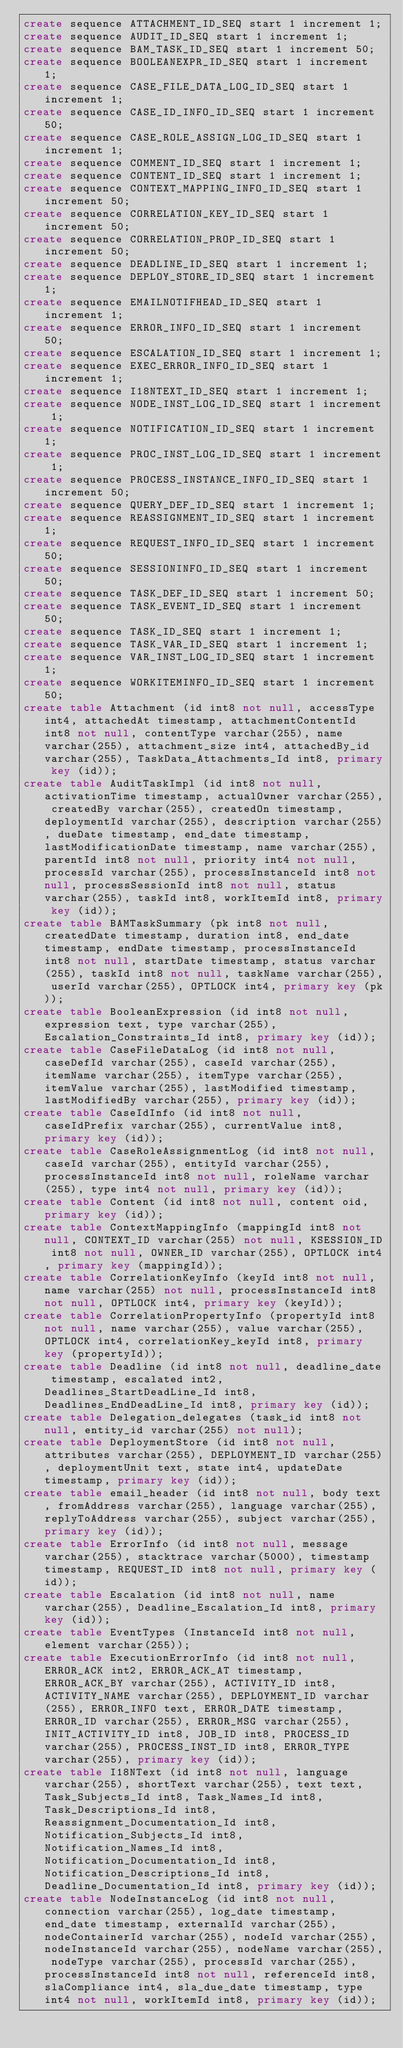<code> <loc_0><loc_0><loc_500><loc_500><_SQL_>create sequence ATTACHMENT_ID_SEQ start 1 increment 1;
create sequence AUDIT_ID_SEQ start 1 increment 1;
create sequence BAM_TASK_ID_SEQ start 1 increment 50;
create sequence BOOLEANEXPR_ID_SEQ start 1 increment 1;
create sequence CASE_FILE_DATA_LOG_ID_SEQ start 1 increment 1;
create sequence CASE_ID_INFO_ID_SEQ start 1 increment 50;
create sequence CASE_ROLE_ASSIGN_LOG_ID_SEQ start 1 increment 1;
create sequence COMMENT_ID_SEQ start 1 increment 1;
create sequence CONTENT_ID_SEQ start 1 increment 1;
create sequence CONTEXT_MAPPING_INFO_ID_SEQ start 1 increment 50;
create sequence CORRELATION_KEY_ID_SEQ start 1 increment 50;
create sequence CORRELATION_PROP_ID_SEQ start 1 increment 50;
create sequence DEADLINE_ID_SEQ start 1 increment 1;
create sequence DEPLOY_STORE_ID_SEQ start 1 increment 1;
create sequence EMAILNOTIFHEAD_ID_SEQ start 1 increment 1;
create sequence ERROR_INFO_ID_SEQ start 1 increment 50;
create sequence ESCALATION_ID_SEQ start 1 increment 1;
create sequence EXEC_ERROR_INFO_ID_SEQ start 1 increment 1;
create sequence I18NTEXT_ID_SEQ start 1 increment 1;
create sequence NODE_INST_LOG_ID_SEQ start 1 increment 1;
create sequence NOTIFICATION_ID_SEQ start 1 increment 1;
create sequence PROC_INST_LOG_ID_SEQ start 1 increment 1;
create sequence PROCESS_INSTANCE_INFO_ID_SEQ start 1 increment 50;
create sequence QUERY_DEF_ID_SEQ start 1 increment 1;
create sequence REASSIGNMENT_ID_SEQ start 1 increment 1;
create sequence REQUEST_INFO_ID_SEQ start 1 increment 50;
create sequence SESSIONINFO_ID_SEQ start 1 increment 50;
create sequence TASK_DEF_ID_SEQ start 1 increment 50;
create sequence TASK_EVENT_ID_SEQ start 1 increment 50;
create sequence TASK_ID_SEQ start 1 increment 1;
create sequence TASK_VAR_ID_SEQ start 1 increment 1;
create sequence VAR_INST_LOG_ID_SEQ start 1 increment 1;
create sequence WORKITEMINFO_ID_SEQ start 1 increment 50;
create table Attachment (id int8 not null, accessType int4, attachedAt timestamp, attachmentContentId int8 not null, contentType varchar(255), name varchar(255), attachment_size int4, attachedBy_id varchar(255), TaskData_Attachments_Id int8, primary key (id));
create table AuditTaskImpl (id int8 not null, activationTime timestamp, actualOwner varchar(255), createdBy varchar(255), createdOn timestamp, deploymentId varchar(255), description varchar(255), dueDate timestamp, end_date timestamp, lastModificationDate timestamp, name varchar(255), parentId int8 not null, priority int4 not null, processId varchar(255), processInstanceId int8 not null, processSessionId int8 not null, status varchar(255), taskId int8, workItemId int8, primary key (id));
create table BAMTaskSummary (pk int8 not null, createdDate timestamp, duration int8, end_date timestamp, endDate timestamp, processInstanceId int8 not null, startDate timestamp, status varchar(255), taskId int8 not null, taskName varchar(255), userId varchar(255), OPTLOCK int4, primary key (pk));
create table BooleanExpression (id int8 not null, expression text, type varchar(255), Escalation_Constraints_Id int8, primary key (id));
create table CaseFileDataLog (id int8 not null, caseDefId varchar(255), caseId varchar(255), itemName varchar(255), itemType varchar(255), itemValue varchar(255), lastModified timestamp, lastModifiedBy varchar(255), primary key (id));
create table CaseIdInfo (id int8 not null, caseIdPrefix varchar(255), currentValue int8, primary key (id));
create table CaseRoleAssignmentLog (id int8 not null, caseId varchar(255), entityId varchar(255), processInstanceId int8 not null, roleName varchar(255), type int4 not null, primary key (id));
create table Content (id int8 not null, content oid, primary key (id));
create table ContextMappingInfo (mappingId int8 not null, CONTEXT_ID varchar(255) not null, KSESSION_ID int8 not null, OWNER_ID varchar(255), OPTLOCK int4, primary key (mappingId));
create table CorrelationKeyInfo (keyId int8 not null, name varchar(255) not null, processInstanceId int8 not null, OPTLOCK int4, primary key (keyId));
create table CorrelationPropertyInfo (propertyId int8 not null, name varchar(255), value varchar(255), OPTLOCK int4, correlationKey_keyId int8, primary key (propertyId));
create table Deadline (id int8 not null, deadline_date timestamp, escalated int2, Deadlines_StartDeadLine_Id int8, Deadlines_EndDeadLine_Id int8, primary key (id));
create table Delegation_delegates (task_id int8 not null, entity_id varchar(255) not null);
create table DeploymentStore (id int8 not null, attributes varchar(255), DEPLOYMENT_ID varchar(255), deploymentUnit text, state int4, updateDate timestamp, primary key (id));
create table email_header (id int8 not null, body text, fromAddress varchar(255), language varchar(255), replyToAddress varchar(255), subject varchar(255), primary key (id));
create table ErrorInfo (id int8 not null, message varchar(255), stacktrace varchar(5000), timestamp timestamp, REQUEST_ID int8 not null, primary key (id));
create table Escalation (id int8 not null, name varchar(255), Deadline_Escalation_Id int8, primary key (id));
create table EventTypes (InstanceId int8 not null, element varchar(255));
create table ExecutionErrorInfo (id int8 not null, ERROR_ACK int2, ERROR_ACK_AT timestamp, ERROR_ACK_BY varchar(255), ACTIVITY_ID int8, ACTIVITY_NAME varchar(255), DEPLOYMENT_ID varchar(255), ERROR_INFO text, ERROR_DATE timestamp, ERROR_ID varchar(255), ERROR_MSG varchar(255), INIT_ACTIVITY_ID int8, JOB_ID int8, PROCESS_ID varchar(255), PROCESS_INST_ID int8, ERROR_TYPE varchar(255), primary key (id));
create table I18NText (id int8 not null, language varchar(255), shortText varchar(255), text text, Task_Subjects_Id int8, Task_Names_Id int8, Task_Descriptions_Id int8, Reassignment_Documentation_Id int8, Notification_Subjects_Id int8, Notification_Names_Id int8, Notification_Documentation_Id int8, Notification_Descriptions_Id int8, Deadline_Documentation_Id int8, primary key (id));
create table NodeInstanceLog (id int8 not null, connection varchar(255), log_date timestamp, end_date timestamp, externalId varchar(255), nodeContainerId varchar(255), nodeId varchar(255), nodeInstanceId varchar(255), nodeName varchar(255), nodeType varchar(255), processId varchar(255), processInstanceId int8 not null, referenceId int8, slaCompliance int4, sla_due_date timestamp, type int4 not null, workItemId int8, primary key (id));</code> 